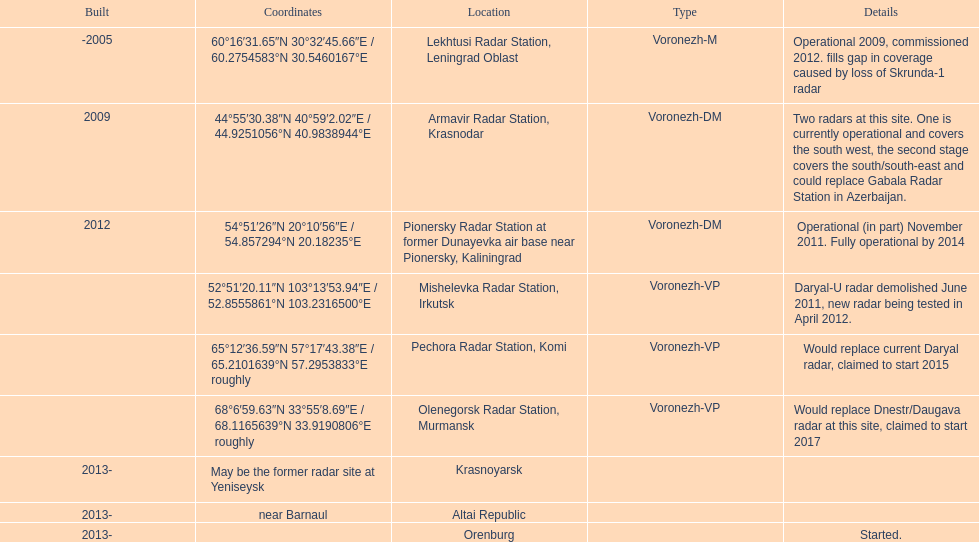Which voronezh radar has already started? Orenburg. Which radar would replace dnestr/daugava? Olenegorsk Radar Station, Murmansk. Which radar started in 2015? Pechora Radar Station, Komi. 